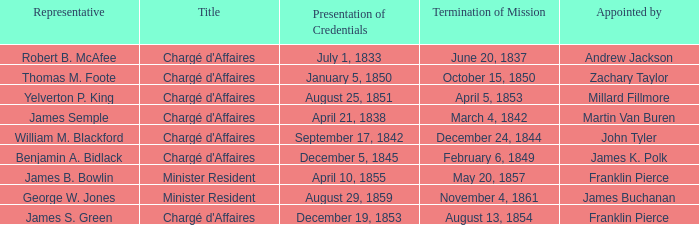Would you be able to parse every entry in this table? {'header': ['Representative', 'Title', 'Presentation of Credentials', 'Termination of Mission', 'Appointed by'], 'rows': [['Robert B. McAfee', "Chargé d'Affaires", 'July 1, 1833', 'June 20, 1837', 'Andrew Jackson'], ['Thomas M. Foote', "Chargé d'Affaires", 'January 5, 1850', 'October 15, 1850', 'Zachary Taylor'], ['Yelverton P. King', "Chargé d'Affaires", 'August 25, 1851', 'April 5, 1853', 'Millard Fillmore'], ['James Semple', "Chargé d'Affaires", 'April 21, 1838', 'March 4, 1842', 'Martin Van Buren'], ['William M. Blackford', "Chargé d'Affaires", 'September 17, 1842', 'December 24, 1844', 'John Tyler'], ['Benjamin A. Bidlack', "Chargé d'Affaires", 'December 5, 1845', 'February 6, 1849', 'James K. Polk'], ['James B. Bowlin', 'Minister Resident', 'April 10, 1855', 'May 20, 1857', 'Franklin Pierce'], ['George W. Jones', 'Minister Resident', 'August 29, 1859', 'November 4, 1861', 'James Buchanan'], ['James S. Green', "Chargé d'Affaires", 'December 19, 1853', 'August 13, 1854', 'Franklin Pierce']]} What Title has a Termination of Mission for August 13, 1854? Chargé d'Affaires. 